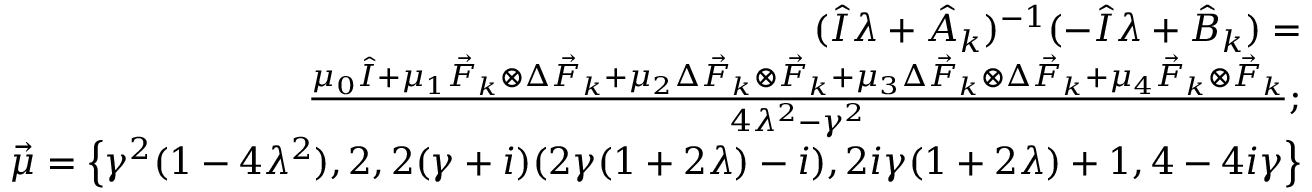Convert formula to latex. <formula><loc_0><loc_0><loc_500><loc_500>\begin{array} { r l r } & { ( \hat { I } \lambda + \hat { A } _ { k } ) ^ { - 1 } ( - \hat { I } \lambda + \hat { B } _ { k } ) = } \\ & { \frac { \mu _ { 0 } \hat { I } + \mu _ { 1 } \vec { F } _ { k } \otimes \Delta \vec { F } _ { k } + \mu _ { 2 } \Delta \vec { F } _ { k } \otimes \vec { F } _ { k } + \mu _ { 3 } \Delta \vec { F } _ { k } \otimes \Delta \vec { F } _ { k } + \mu _ { 4 } \vec { F } _ { k } \otimes \vec { F } _ { k } } { 4 \lambda ^ { 2 } - \gamma ^ { 2 } } ; } \\ & { \vec { \mu } = \left \{ \gamma ^ { 2 } ( 1 - 4 \lambda ^ { 2 } ) , 2 , 2 ( \gamma + i ) ( 2 \gamma ( 1 + 2 \lambda ) - i ) , 2 i \gamma ( 1 + 2 \lambda ) + 1 , 4 - 4 i \gamma \right \} } \end{array}</formula> 